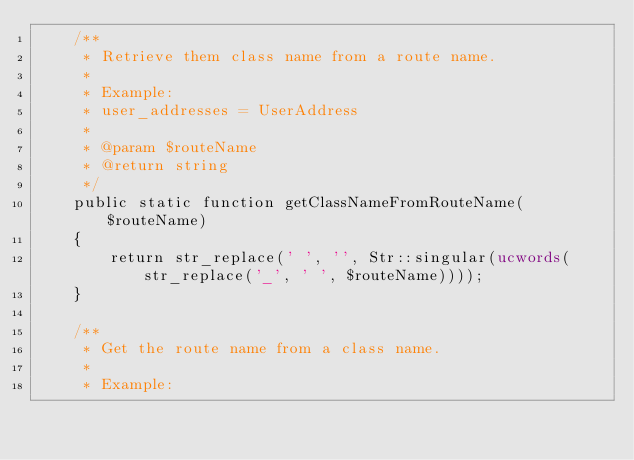<code> <loc_0><loc_0><loc_500><loc_500><_PHP_>    /**
     * Retrieve them class name from a route name.
     *
     * Example:
     * user_addresses = UserAddress
     *
     * @param $routeName
     * @return string
     */
    public static function getClassNameFromRouteName($routeName)
    {
        return str_replace(' ', '', Str::singular(ucwords(str_replace('_', ' ', $routeName))));
    }

    /**
     * Get the route name from a class name.
     *
     * Example:</code> 